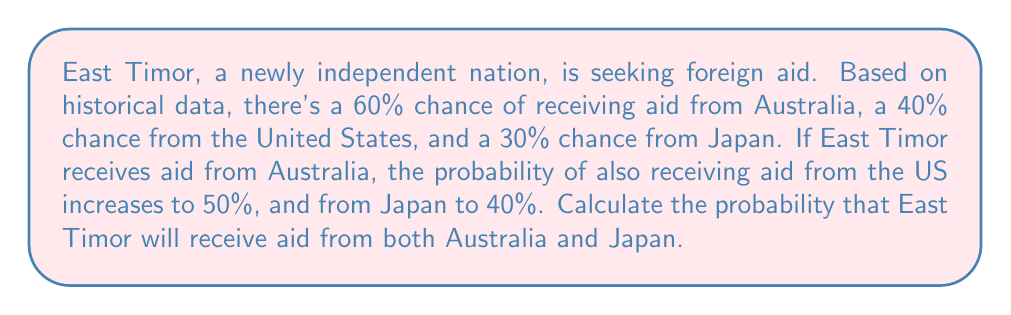Give your solution to this math problem. Let's approach this step-by-step using conditional probability:

1) Let A = event of receiving aid from Australia
   J = event of receiving aid from Japan

2) We're given:
   P(A) = 0.60
   P(J|A) = 0.40 (probability of receiving aid from Japan given that aid is received from Australia)

3) We want to find P(A ∩ J), the probability of receiving aid from both Australia and Japan.

4) We can use the formula for conditional probability:

   $$P(J|A) = \frac{P(A ∩ J)}{P(A)}$$

5) Rearranging this formula:

   $$P(A ∩ J) = P(J|A) * P(A)$$

6) Now we can substitute the values we know:

   $$P(A ∩ J) = 0.40 * 0.60$$

7) Calculating:

   $$P(A ∩ J) = 0.24$$

Therefore, the probability of East Timor receiving aid from both Australia and Japan is 0.24 or 24%.
Answer: 0.24 